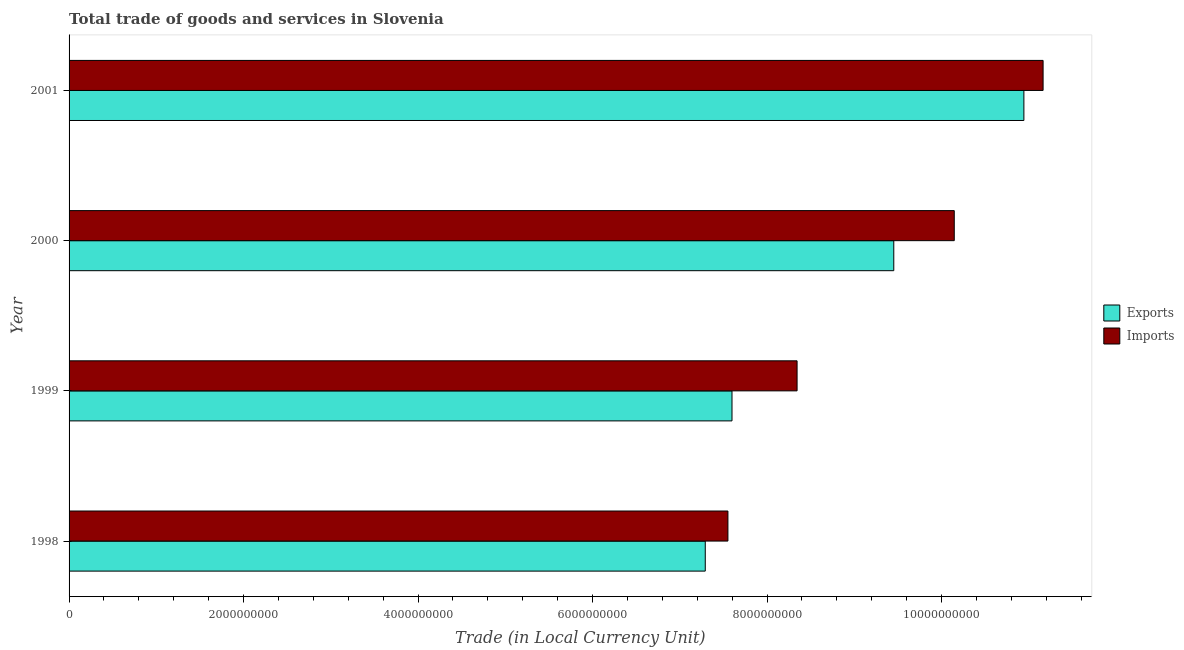How many different coloured bars are there?
Your answer should be very brief. 2. How many bars are there on the 3rd tick from the top?
Your response must be concise. 2. How many bars are there on the 3rd tick from the bottom?
Provide a succinct answer. 2. What is the export of goods and services in 1999?
Offer a very short reply. 7.60e+09. Across all years, what is the maximum export of goods and services?
Your answer should be compact. 1.09e+1. Across all years, what is the minimum imports of goods and services?
Your answer should be compact. 7.55e+09. In which year was the imports of goods and services minimum?
Offer a terse response. 1998. What is the total imports of goods and services in the graph?
Your answer should be compact. 3.72e+1. What is the difference between the imports of goods and services in 2000 and that in 2001?
Make the answer very short. -1.02e+09. What is the difference between the export of goods and services in 2000 and the imports of goods and services in 1998?
Your answer should be compact. 1.90e+09. What is the average imports of goods and services per year?
Your response must be concise. 9.30e+09. In the year 2001, what is the difference between the imports of goods and services and export of goods and services?
Offer a terse response. 2.20e+08. Is the difference between the imports of goods and services in 1999 and 2000 greater than the difference between the export of goods and services in 1999 and 2000?
Give a very brief answer. Yes. What is the difference between the highest and the second highest export of goods and services?
Your answer should be compact. 1.49e+09. What is the difference between the highest and the lowest imports of goods and services?
Provide a succinct answer. 3.61e+09. Is the sum of the export of goods and services in 1999 and 2000 greater than the maximum imports of goods and services across all years?
Ensure brevity in your answer.  Yes. What does the 2nd bar from the top in 2001 represents?
Your response must be concise. Exports. What does the 2nd bar from the bottom in 1999 represents?
Your answer should be very brief. Imports. Are all the bars in the graph horizontal?
Make the answer very short. Yes. What is the difference between two consecutive major ticks on the X-axis?
Provide a short and direct response. 2.00e+09. How many legend labels are there?
Offer a terse response. 2. What is the title of the graph?
Offer a very short reply. Total trade of goods and services in Slovenia. What is the label or title of the X-axis?
Make the answer very short. Trade (in Local Currency Unit). What is the Trade (in Local Currency Unit) in Exports in 1998?
Give a very brief answer. 7.29e+09. What is the Trade (in Local Currency Unit) in Imports in 1998?
Offer a very short reply. 7.55e+09. What is the Trade (in Local Currency Unit) of Exports in 1999?
Ensure brevity in your answer.  7.60e+09. What is the Trade (in Local Currency Unit) of Imports in 1999?
Offer a terse response. 8.34e+09. What is the Trade (in Local Currency Unit) in Exports in 2000?
Your response must be concise. 9.45e+09. What is the Trade (in Local Currency Unit) in Imports in 2000?
Offer a terse response. 1.01e+1. What is the Trade (in Local Currency Unit) in Exports in 2001?
Keep it short and to the point. 1.09e+1. What is the Trade (in Local Currency Unit) in Imports in 2001?
Give a very brief answer. 1.12e+1. Across all years, what is the maximum Trade (in Local Currency Unit) of Exports?
Ensure brevity in your answer.  1.09e+1. Across all years, what is the maximum Trade (in Local Currency Unit) of Imports?
Keep it short and to the point. 1.12e+1. Across all years, what is the minimum Trade (in Local Currency Unit) of Exports?
Your response must be concise. 7.29e+09. Across all years, what is the minimum Trade (in Local Currency Unit) of Imports?
Make the answer very short. 7.55e+09. What is the total Trade (in Local Currency Unit) in Exports in the graph?
Provide a succinct answer. 3.53e+1. What is the total Trade (in Local Currency Unit) of Imports in the graph?
Your answer should be very brief. 3.72e+1. What is the difference between the Trade (in Local Currency Unit) in Exports in 1998 and that in 1999?
Ensure brevity in your answer.  -3.06e+08. What is the difference between the Trade (in Local Currency Unit) in Imports in 1998 and that in 1999?
Your answer should be very brief. -7.93e+08. What is the difference between the Trade (in Local Currency Unit) in Exports in 1998 and that in 2000?
Keep it short and to the point. -2.16e+09. What is the difference between the Trade (in Local Currency Unit) of Imports in 1998 and that in 2000?
Offer a very short reply. -2.59e+09. What is the difference between the Trade (in Local Currency Unit) of Exports in 1998 and that in 2001?
Keep it short and to the point. -3.65e+09. What is the difference between the Trade (in Local Currency Unit) of Imports in 1998 and that in 2001?
Ensure brevity in your answer.  -3.61e+09. What is the difference between the Trade (in Local Currency Unit) in Exports in 1999 and that in 2000?
Your response must be concise. -1.85e+09. What is the difference between the Trade (in Local Currency Unit) of Imports in 1999 and that in 2000?
Provide a short and direct response. -1.80e+09. What is the difference between the Trade (in Local Currency Unit) of Exports in 1999 and that in 2001?
Give a very brief answer. -3.35e+09. What is the difference between the Trade (in Local Currency Unit) of Imports in 1999 and that in 2001?
Make the answer very short. -2.82e+09. What is the difference between the Trade (in Local Currency Unit) of Exports in 2000 and that in 2001?
Offer a very short reply. -1.49e+09. What is the difference between the Trade (in Local Currency Unit) in Imports in 2000 and that in 2001?
Your answer should be compact. -1.02e+09. What is the difference between the Trade (in Local Currency Unit) of Exports in 1998 and the Trade (in Local Currency Unit) of Imports in 1999?
Your answer should be very brief. -1.05e+09. What is the difference between the Trade (in Local Currency Unit) in Exports in 1998 and the Trade (in Local Currency Unit) in Imports in 2000?
Keep it short and to the point. -2.85e+09. What is the difference between the Trade (in Local Currency Unit) in Exports in 1998 and the Trade (in Local Currency Unit) in Imports in 2001?
Your response must be concise. -3.87e+09. What is the difference between the Trade (in Local Currency Unit) of Exports in 1999 and the Trade (in Local Currency Unit) of Imports in 2000?
Your answer should be very brief. -2.55e+09. What is the difference between the Trade (in Local Currency Unit) of Exports in 1999 and the Trade (in Local Currency Unit) of Imports in 2001?
Give a very brief answer. -3.57e+09. What is the difference between the Trade (in Local Currency Unit) in Exports in 2000 and the Trade (in Local Currency Unit) in Imports in 2001?
Your response must be concise. -1.71e+09. What is the average Trade (in Local Currency Unit) of Exports per year?
Offer a terse response. 8.82e+09. What is the average Trade (in Local Currency Unit) in Imports per year?
Make the answer very short. 9.30e+09. In the year 1998, what is the difference between the Trade (in Local Currency Unit) in Exports and Trade (in Local Currency Unit) in Imports?
Ensure brevity in your answer.  -2.60e+08. In the year 1999, what is the difference between the Trade (in Local Currency Unit) of Exports and Trade (in Local Currency Unit) of Imports?
Offer a very short reply. -7.46e+08. In the year 2000, what is the difference between the Trade (in Local Currency Unit) of Exports and Trade (in Local Currency Unit) of Imports?
Your answer should be very brief. -6.93e+08. In the year 2001, what is the difference between the Trade (in Local Currency Unit) in Exports and Trade (in Local Currency Unit) in Imports?
Make the answer very short. -2.20e+08. What is the ratio of the Trade (in Local Currency Unit) of Exports in 1998 to that in 1999?
Provide a short and direct response. 0.96. What is the ratio of the Trade (in Local Currency Unit) in Imports in 1998 to that in 1999?
Your answer should be very brief. 0.91. What is the ratio of the Trade (in Local Currency Unit) of Exports in 1998 to that in 2000?
Ensure brevity in your answer.  0.77. What is the ratio of the Trade (in Local Currency Unit) of Imports in 1998 to that in 2000?
Provide a short and direct response. 0.74. What is the ratio of the Trade (in Local Currency Unit) in Exports in 1998 to that in 2001?
Your answer should be very brief. 0.67. What is the ratio of the Trade (in Local Currency Unit) of Imports in 1998 to that in 2001?
Your answer should be very brief. 0.68. What is the ratio of the Trade (in Local Currency Unit) of Exports in 1999 to that in 2000?
Keep it short and to the point. 0.8. What is the ratio of the Trade (in Local Currency Unit) of Imports in 1999 to that in 2000?
Your answer should be compact. 0.82. What is the ratio of the Trade (in Local Currency Unit) in Exports in 1999 to that in 2001?
Provide a succinct answer. 0.69. What is the ratio of the Trade (in Local Currency Unit) in Imports in 1999 to that in 2001?
Give a very brief answer. 0.75. What is the ratio of the Trade (in Local Currency Unit) of Exports in 2000 to that in 2001?
Your response must be concise. 0.86. What is the ratio of the Trade (in Local Currency Unit) of Imports in 2000 to that in 2001?
Give a very brief answer. 0.91. What is the difference between the highest and the second highest Trade (in Local Currency Unit) in Exports?
Your answer should be compact. 1.49e+09. What is the difference between the highest and the second highest Trade (in Local Currency Unit) in Imports?
Give a very brief answer. 1.02e+09. What is the difference between the highest and the lowest Trade (in Local Currency Unit) in Exports?
Your response must be concise. 3.65e+09. What is the difference between the highest and the lowest Trade (in Local Currency Unit) of Imports?
Give a very brief answer. 3.61e+09. 